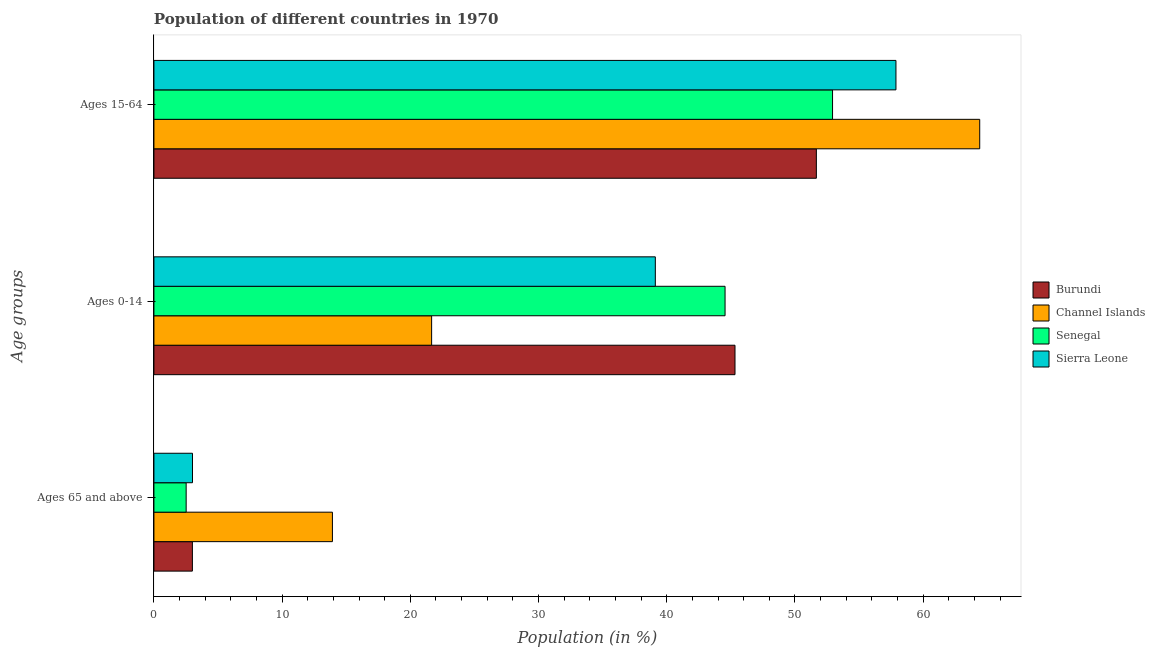How many different coloured bars are there?
Offer a very short reply. 4. How many groups of bars are there?
Provide a succinct answer. 3. How many bars are there on the 1st tick from the top?
Keep it short and to the point. 4. What is the label of the 2nd group of bars from the top?
Offer a very short reply. Ages 0-14. What is the percentage of population within the age-group 0-14 in Burundi?
Give a very brief answer. 45.33. Across all countries, what is the maximum percentage of population within the age-group 0-14?
Keep it short and to the point. 45.33. Across all countries, what is the minimum percentage of population within the age-group 15-64?
Provide a short and direct response. 51.67. In which country was the percentage of population within the age-group of 65 and above maximum?
Make the answer very short. Channel Islands. In which country was the percentage of population within the age-group 15-64 minimum?
Offer a very short reply. Burundi. What is the total percentage of population within the age-group 0-14 in the graph?
Your response must be concise. 150.65. What is the difference between the percentage of population within the age-group 0-14 in Sierra Leone and that in Senegal?
Provide a short and direct response. -5.44. What is the difference between the percentage of population within the age-group of 65 and above in Channel Islands and the percentage of population within the age-group 15-64 in Sierra Leone?
Your response must be concise. -43.96. What is the average percentage of population within the age-group 15-64 per country?
Offer a very short reply. 56.73. What is the difference between the percentage of population within the age-group 15-64 and percentage of population within the age-group 0-14 in Channel Islands?
Offer a terse response. 42.75. In how many countries, is the percentage of population within the age-group 0-14 greater than 38 %?
Provide a succinct answer. 3. What is the ratio of the percentage of population within the age-group 0-14 in Senegal to that in Sierra Leone?
Provide a succinct answer. 1.14. Is the percentage of population within the age-group 15-64 in Sierra Leone less than that in Channel Islands?
Provide a succinct answer. Yes. What is the difference between the highest and the second highest percentage of population within the age-group 0-14?
Offer a very short reply. 0.78. What is the difference between the highest and the lowest percentage of population within the age-group of 65 and above?
Offer a very short reply. 11.41. In how many countries, is the percentage of population within the age-group 0-14 greater than the average percentage of population within the age-group 0-14 taken over all countries?
Your answer should be compact. 3. What does the 3rd bar from the top in Ages 15-64 represents?
Provide a succinct answer. Channel Islands. What does the 3rd bar from the bottom in Ages 0-14 represents?
Ensure brevity in your answer.  Senegal. How many bars are there?
Offer a very short reply. 12. Where does the legend appear in the graph?
Your response must be concise. Center right. What is the title of the graph?
Provide a short and direct response. Population of different countries in 1970. Does "Papua New Guinea" appear as one of the legend labels in the graph?
Ensure brevity in your answer.  No. What is the label or title of the X-axis?
Provide a succinct answer. Population (in %). What is the label or title of the Y-axis?
Provide a succinct answer. Age groups. What is the Population (in %) of Burundi in Ages 65 and above?
Your answer should be compact. 3. What is the Population (in %) in Channel Islands in Ages 65 and above?
Ensure brevity in your answer.  13.92. What is the Population (in %) of Senegal in Ages 65 and above?
Your response must be concise. 2.51. What is the Population (in %) of Sierra Leone in Ages 65 and above?
Provide a short and direct response. 3.01. What is the Population (in %) of Burundi in Ages 0-14?
Provide a short and direct response. 45.33. What is the Population (in %) of Channel Islands in Ages 0-14?
Your answer should be very brief. 21.66. What is the Population (in %) in Senegal in Ages 0-14?
Keep it short and to the point. 44.55. What is the Population (in %) of Sierra Leone in Ages 0-14?
Offer a terse response. 39.11. What is the Population (in %) of Burundi in Ages 15-64?
Your response must be concise. 51.67. What is the Population (in %) of Channel Islands in Ages 15-64?
Keep it short and to the point. 64.42. What is the Population (in %) in Senegal in Ages 15-64?
Make the answer very short. 52.94. What is the Population (in %) of Sierra Leone in Ages 15-64?
Offer a very short reply. 57.88. Across all Age groups, what is the maximum Population (in %) in Burundi?
Offer a terse response. 51.67. Across all Age groups, what is the maximum Population (in %) in Channel Islands?
Ensure brevity in your answer.  64.42. Across all Age groups, what is the maximum Population (in %) in Senegal?
Provide a succinct answer. 52.94. Across all Age groups, what is the maximum Population (in %) in Sierra Leone?
Provide a succinct answer. 57.88. Across all Age groups, what is the minimum Population (in %) of Burundi?
Ensure brevity in your answer.  3. Across all Age groups, what is the minimum Population (in %) in Channel Islands?
Your answer should be compact. 13.92. Across all Age groups, what is the minimum Population (in %) of Senegal?
Offer a very short reply. 2.51. Across all Age groups, what is the minimum Population (in %) in Sierra Leone?
Provide a short and direct response. 3.01. What is the total Population (in %) of Burundi in the graph?
Make the answer very short. 100. What is the total Population (in %) of Senegal in the graph?
Your answer should be compact. 100. What is the difference between the Population (in %) in Burundi in Ages 65 and above and that in Ages 0-14?
Your answer should be very brief. -42.33. What is the difference between the Population (in %) of Channel Islands in Ages 65 and above and that in Ages 0-14?
Offer a terse response. -7.74. What is the difference between the Population (in %) in Senegal in Ages 65 and above and that in Ages 0-14?
Ensure brevity in your answer.  -42.04. What is the difference between the Population (in %) in Sierra Leone in Ages 65 and above and that in Ages 0-14?
Offer a terse response. -36.1. What is the difference between the Population (in %) in Burundi in Ages 65 and above and that in Ages 15-64?
Provide a short and direct response. -48.67. What is the difference between the Population (in %) of Channel Islands in Ages 65 and above and that in Ages 15-64?
Give a very brief answer. -50.49. What is the difference between the Population (in %) in Senegal in Ages 65 and above and that in Ages 15-64?
Offer a very short reply. -50.42. What is the difference between the Population (in %) of Sierra Leone in Ages 65 and above and that in Ages 15-64?
Provide a succinct answer. -54.87. What is the difference between the Population (in %) in Burundi in Ages 0-14 and that in Ages 15-64?
Keep it short and to the point. -6.35. What is the difference between the Population (in %) of Channel Islands in Ages 0-14 and that in Ages 15-64?
Provide a short and direct response. -42.75. What is the difference between the Population (in %) in Senegal in Ages 0-14 and that in Ages 15-64?
Provide a short and direct response. -8.38. What is the difference between the Population (in %) of Sierra Leone in Ages 0-14 and that in Ages 15-64?
Your answer should be compact. -18.77. What is the difference between the Population (in %) in Burundi in Ages 65 and above and the Population (in %) in Channel Islands in Ages 0-14?
Your answer should be compact. -18.66. What is the difference between the Population (in %) in Burundi in Ages 65 and above and the Population (in %) in Senegal in Ages 0-14?
Keep it short and to the point. -41.55. What is the difference between the Population (in %) in Burundi in Ages 65 and above and the Population (in %) in Sierra Leone in Ages 0-14?
Make the answer very short. -36.11. What is the difference between the Population (in %) of Channel Islands in Ages 65 and above and the Population (in %) of Senegal in Ages 0-14?
Your response must be concise. -30.63. What is the difference between the Population (in %) of Channel Islands in Ages 65 and above and the Population (in %) of Sierra Leone in Ages 0-14?
Your response must be concise. -25.19. What is the difference between the Population (in %) in Senegal in Ages 65 and above and the Population (in %) in Sierra Leone in Ages 0-14?
Your answer should be compact. -36.6. What is the difference between the Population (in %) in Burundi in Ages 65 and above and the Population (in %) in Channel Islands in Ages 15-64?
Give a very brief answer. -61.41. What is the difference between the Population (in %) in Burundi in Ages 65 and above and the Population (in %) in Senegal in Ages 15-64?
Your answer should be compact. -49.93. What is the difference between the Population (in %) of Burundi in Ages 65 and above and the Population (in %) of Sierra Leone in Ages 15-64?
Your answer should be compact. -54.88. What is the difference between the Population (in %) of Channel Islands in Ages 65 and above and the Population (in %) of Senegal in Ages 15-64?
Give a very brief answer. -39.01. What is the difference between the Population (in %) in Channel Islands in Ages 65 and above and the Population (in %) in Sierra Leone in Ages 15-64?
Ensure brevity in your answer.  -43.96. What is the difference between the Population (in %) of Senegal in Ages 65 and above and the Population (in %) of Sierra Leone in Ages 15-64?
Your response must be concise. -55.37. What is the difference between the Population (in %) in Burundi in Ages 0-14 and the Population (in %) in Channel Islands in Ages 15-64?
Provide a short and direct response. -19.09. What is the difference between the Population (in %) in Burundi in Ages 0-14 and the Population (in %) in Senegal in Ages 15-64?
Give a very brief answer. -7.61. What is the difference between the Population (in %) of Burundi in Ages 0-14 and the Population (in %) of Sierra Leone in Ages 15-64?
Your answer should be very brief. -12.55. What is the difference between the Population (in %) of Channel Islands in Ages 0-14 and the Population (in %) of Senegal in Ages 15-64?
Your answer should be compact. -31.27. What is the difference between the Population (in %) of Channel Islands in Ages 0-14 and the Population (in %) of Sierra Leone in Ages 15-64?
Offer a terse response. -36.22. What is the difference between the Population (in %) in Senegal in Ages 0-14 and the Population (in %) in Sierra Leone in Ages 15-64?
Provide a short and direct response. -13.33. What is the average Population (in %) in Burundi per Age groups?
Make the answer very short. 33.33. What is the average Population (in %) in Channel Islands per Age groups?
Ensure brevity in your answer.  33.33. What is the average Population (in %) of Senegal per Age groups?
Provide a short and direct response. 33.33. What is the average Population (in %) of Sierra Leone per Age groups?
Provide a short and direct response. 33.33. What is the difference between the Population (in %) in Burundi and Population (in %) in Channel Islands in Ages 65 and above?
Your answer should be very brief. -10.92. What is the difference between the Population (in %) in Burundi and Population (in %) in Senegal in Ages 65 and above?
Provide a short and direct response. 0.49. What is the difference between the Population (in %) in Burundi and Population (in %) in Sierra Leone in Ages 65 and above?
Offer a terse response. -0.01. What is the difference between the Population (in %) in Channel Islands and Population (in %) in Senegal in Ages 65 and above?
Keep it short and to the point. 11.41. What is the difference between the Population (in %) in Channel Islands and Population (in %) in Sierra Leone in Ages 65 and above?
Offer a very short reply. 10.92. What is the difference between the Population (in %) in Senegal and Population (in %) in Sierra Leone in Ages 65 and above?
Ensure brevity in your answer.  -0.49. What is the difference between the Population (in %) of Burundi and Population (in %) of Channel Islands in Ages 0-14?
Provide a succinct answer. 23.66. What is the difference between the Population (in %) of Burundi and Population (in %) of Senegal in Ages 0-14?
Provide a succinct answer. 0.78. What is the difference between the Population (in %) of Burundi and Population (in %) of Sierra Leone in Ages 0-14?
Ensure brevity in your answer.  6.22. What is the difference between the Population (in %) in Channel Islands and Population (in %) in Senegal in Ages 0-14?
Offer a very short reply. -22.89. What is the difference between the Population (in %) of Channel Islands and Population (in %) of Sierra Leone in Ages 0-14?
Your answer should be compact. -17.45. What is the difference between the Population (in %) of Senegal and Population (in %) of Sierra Leone in Ages 0-14?
Provide a succinct answer. 5.44. What is the difference between the Population (in %) of Burundi and Population (in %) of Channel Islands in Ages 15-64?
Your answer should be compact. -12.74. What is the difference between the Population (in %) in Burundi and Population (in %) in Senegal in Ages 15-64?
Your answer should be very brief. -1.26. What is the difference between the Population (in %) in Burundi and Population (in %) in Sierra Leone in Ages 15-64?
Provide a succinct answer. -6.21. What is the difference between the Population (in %) of Channel Islands and Population (in %) of Senegal in Ages 15-64?
Provide a short and direct response. 11.48. What is the difference between the Population (in %) in Channel Islands and Population (in %) in Sierra Leone in Ages 15-64?
Provide a short and direct response. 6.53. What is the difference between the Population (in %) in Senegal and Population (in %) in Sierra Leone in Ages 15-64?
Your response must be concise. -4.95. What is the ratio of the Population (in %) in Burundi in Ages 65 and above to that in Ages 0-14?
Ensure brevity in your answer.  0.07. What is the ratio of the Population (in %) in Channel Islands in Ages 65 and above to that in Ages 0-14?
Keep it short and to the point. 0.64. What is the ratio of the Population (in %) of Senegal in Ages 65 and above to that in Ages 0-14?
Provide a short and direct response. 0.06. What is the ratio of the Population (in %) of Sierra Leone in Ages 65 and above to that in Ages 0-14?
Offer a very short reply. 0.08. What is the ratio of the Population (in %) in Burundi in Ages 65 and above to that in Ages 15-64?
Provide a short and direct response. 0.06. What is the ratio of the Population (in %) of Channel Islands in Ages 65 and above to that in Ages 15-64?
Your response must be concise. 0.22. What is the ratio of the Population (in %) of Senegal in Ages 65 and above to that in Ages 15-64?
Give a very brief answer. 0.05. What is the ratio of the Population (in %) in Sierra Leone in Ages 65 and above to that in Ages 15-64?
Make the answer very short. 0.05. What is the ratio of the Population (in %) of Burundi in Ages 0-14 to that in Ages 15-64?
Your answer should be very brief. 0.88. What is the ratio of the Population (in %) of Channel Islands in Ages 0-14 to that in Ages 15-64?
Offer a terse response. 0.34. What is the ratio of the Population (in %) of Senegal in Ages 0-14 to that in Ages 15-64?
Ensure brevity in your answer.  0.84. What is the ratio of the Population (in %) of Sierra Leone in Ages 0-14 to that in Ages 15-64?
Your response must be concise. 0.68. What is the difference between the highest and the second highest Population (in %) in Burundi?
Make the answer very short. 6.35. What is the difference between the highest and the second highest Population (in %) in Channel Islands?
Offer a very short reply. 42.75. What is the difference between the highest and the second highest Population (in %) of Senegal?
Your answer should be very brief. 8.38. What is the difference between the highest and the second highest Population (in %) in Sierra Leone?
Make the answer very short. 18.77. What is the difference between the highest and the lowest Population (in %) of Burundi?
Make the answer very short. 48.67. What is the difference between the highest and the lowest Population (in %) in Channel Islands?
Offer a very short reply. 50.49. What is the difference between the highest and the lowest Population (in %) in Senegal?
Your response must be concise. 50.42. What is the difference between the highest and the lowest Population (in %) of Sierra Leone?
Your answer should be compact. 54.87. 